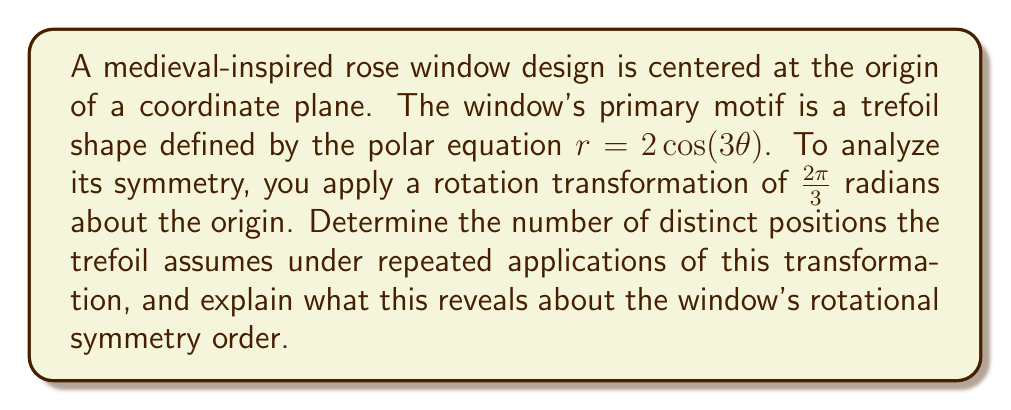Can you solve this math problem? To solve this problem, we need to understand the concept of rotational symmetry and how it applies to the given rose window design. Let's break it down step-by-step:

1) The trefoil shape is defined by the polar equation $r = 2\cos(3\theta)$. This equation inherently creates a shape with three-fold symmetry.

2) The rotation transformation applied is $\frac{2\pi}{3}$ radians, which is equivalent to a 120° rotation.

3) To determine how many distinct positions the trefoil assumes, we need to apply this rotation repeatedly and observe when the shape returns to its original position.

4) Let's apply the rotation:
   - Original position: $\theta$
   - After one rotation: $\theta + \frac{2\pi}{3}$
   - After two rotations: $\theta + \frac{4\pi}{3}$
   - After three rotations: $\theta + 2\pi$

5) When we rotate by $2\pi$, we complete a full rotation and return to the original position.

6) This means that after three applications of the $\frac{2\pi}{3}$ rotation, the trefoil returns to its original position.

7) During this process, the trefoil assumes three distinct positions:
   - The original position
   - After a $\frac{2\pi}{3}$ rotation
   - After a $\frac{4\pi}{3}$ rotation

8) The number of distinct positions (3) reveals the rotational symmetry order of the window design.

9) In general, an n-fold rotational symmetry means that the shape looks the same after a rotation of $\frac{2\pi}{n}$ radians.

Therefore, the trefoil assumes 3 distinct positions under repeated applications of the $\frac{2\pi}{3}$ rotation, indicating that the rose window has 3-fold rotational symmetry.
Answer: The trefoil assumes 3 distinct positions under repeated applications of the $\frac{2\pi}{3}$ rotation, revealing that the rose window design has 3-fold rotational symmetry. 